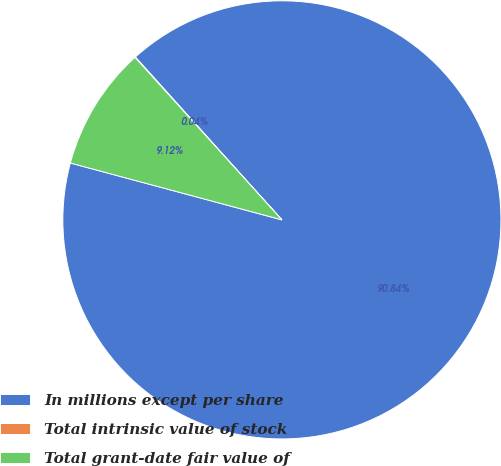Convert chart. <chart><loc_0><loc_0><loc_500><loc_500><pie_chart><fcel>In millions except per share<fcel>Total intrinsic value of stock<fcel>Total grant-date fair value of<nl><fcel>90.85%<fcel>0.04%<fcel>9.12%<nl></chart> 